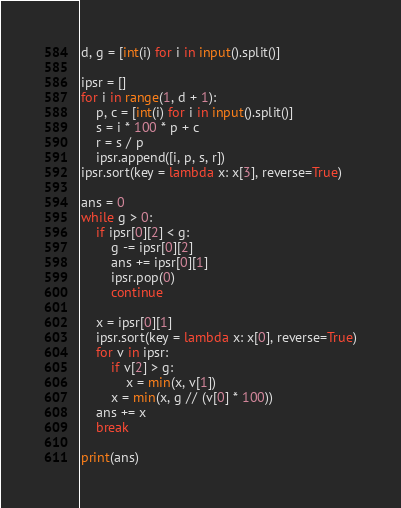Convert code to text. <code><loc_0><loc_0><loc_500><loc_500><_Python_>d, g = [int(i) for i in input().split()]

ipsr = []
for i in range(1, d + 1):
    p, c = [int(i) for i in input().split()]
    s = i * 100 * p + c
    r = s / p
    ipsr.append([i, p, s, r])
ipsr.sort(key = lambda x: x[3], reverse=True)

ans = 0
while g > 0:
    if ipsr[0][2] < g:
        g -= ipsr[0][2]
        ans += ipsr[0][1]
        ipsr.pop(0)
        continue

    x = ipsr[0][1]
    ipsr.sort(key = lambda x: x[0], reverse=True)
    for v in ipsr:
        if v[2] > g:
            x = min(x, v[1])
        x = min(x, g // (v[0] * 100))
    ans += x
    break

print(ans)</code> 